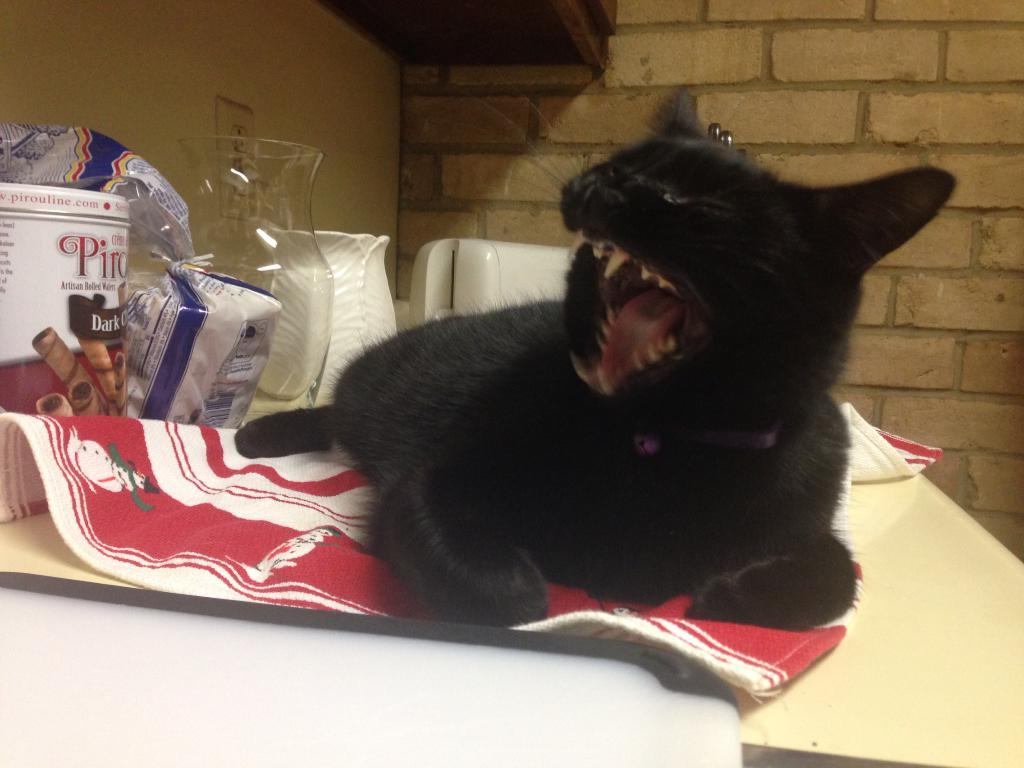What type of animal is in the image? There is a cat in the image. What container is visible in the image? There is a jar in the image. What is covering the jar? There is a cover in the image. What type of storage container is in the image? There is a box in the image. What type of fabric is in the image? There is a towel in the image. Where are the objects located in the image? The objects are on a table. What is visible in the background of the image? There is a wall in the image. Can you see the cat's body swimming in the lake in the image? There is no lake present in the image, and the cat is not swimming. 